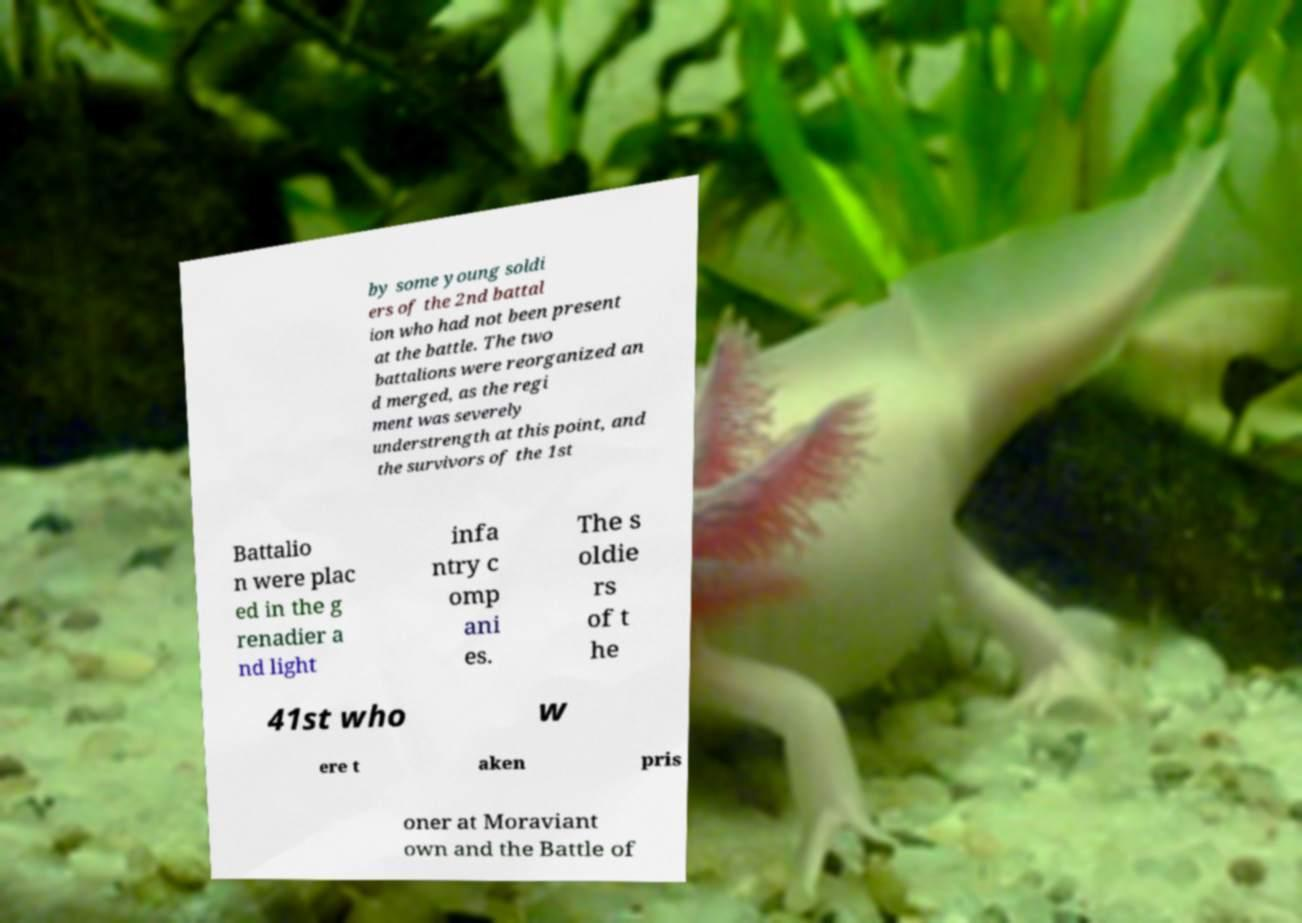Can you accurately transcribe the text from the provided image for me? by some young soldi ers of the 2nd battal ion who had not been present at the battle. The two battalions were reorganized an d merged, as the regi ment was severely understrength at this point, and the survivors of the 1st Battalio n were plac ed in the g renadier a nd light infa ntry c omp ani es. The s oldie rs of t he 41st who w ere t aken pris oner at Moraviant own and the Battle of 